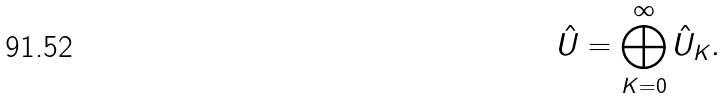<formula> <loc_0><loc_0><loc_500><loc_500>\hat { U } = \bigoplus _ { K = 0 } ^ { \infty } \hat { U } _ { K } .</formula> 